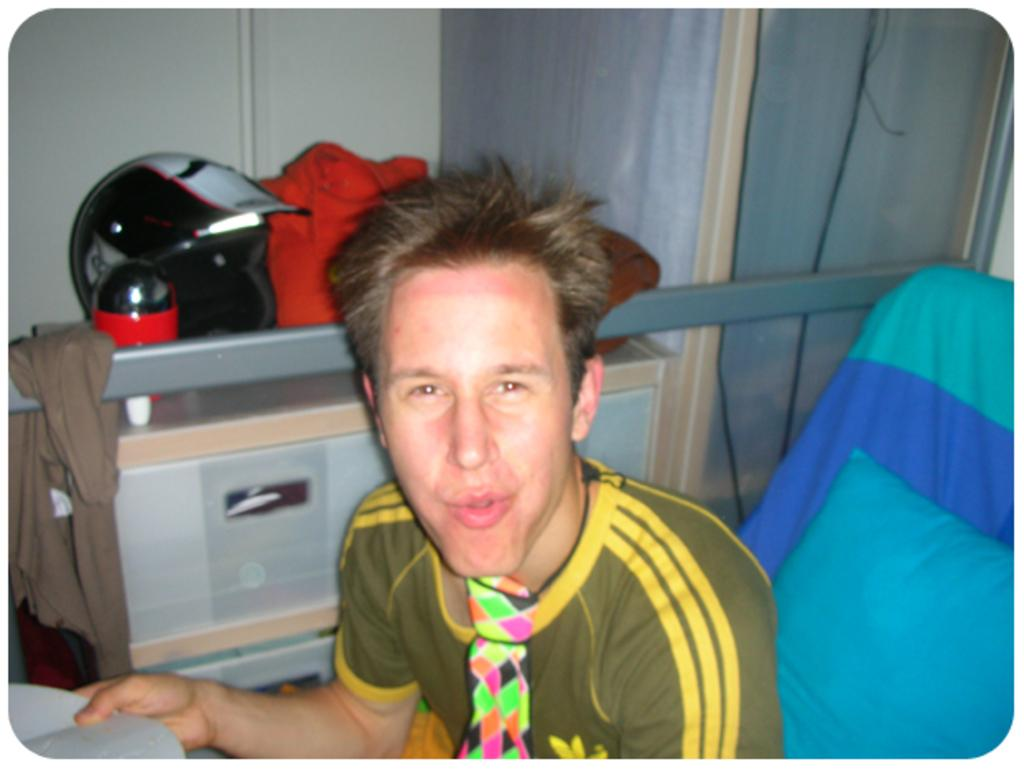What is the person in the image doing? The person is sitting on a chair in the image. What is the person holding while sitting on the chair? The person is holding a book. What can be seen in the background of the image? There are objects on a table and a cupboard in the background of the image. What type of structure is visible in the background? There is a wall in the background of the image. What type of trains can be seen in the image? There are no trains present in the image. What is the person's interest in the book they are holding? The image does not provide information about the person's interest in the book they are holding. 